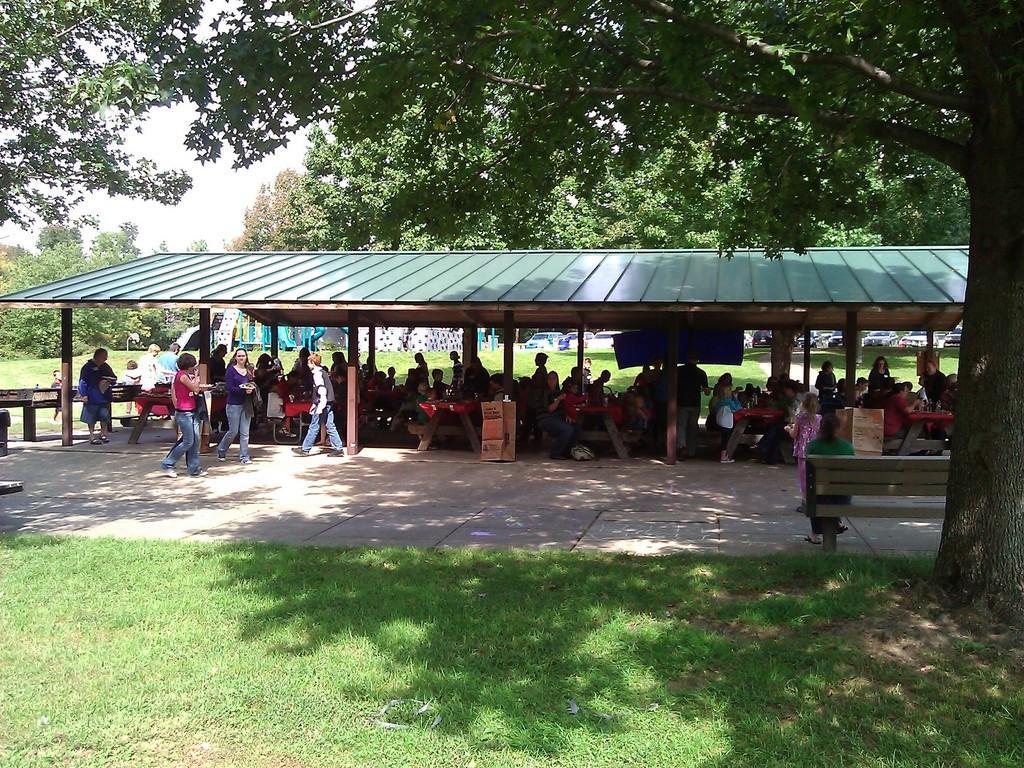Please provide a concise description of this image. In this picture we can see a few people are sitting on the chair. Some people are walking on the path. We can see a person sitting on the bench on the right side. Some grass is visible on the ground. There are some trees and vehicles in the background. 